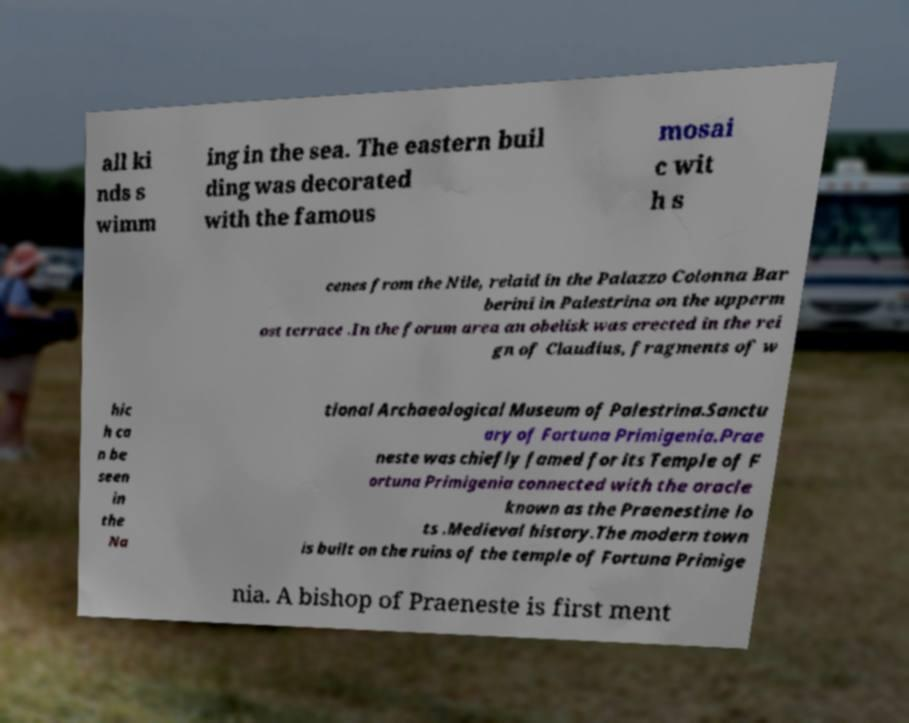Please read and relay the text visible in this image. What does it say? all ki nds s wimm ing in the sea. The eastern buil ding was decorated with the famous mosai c wit h s cenes from the Nile, relaid in the Palazzo Colonna Bar berini in Palestrina on the upperm ost terrace .In the forum area an obelisk was erected in the rei gn of Claudius, fragments of w hic h ca n be seen in the Na tional Archaeological Museum of Palestrina.Sanctu ary of Fortuna Primigenia.Prae neste was chiefly famed for its Temple of F ortuna Primigenia connected with the oracle known as the Praenestine lo ts .Medieval history.The modern town is built on the ruins of the temple of Fortuna Primige nia. A bishop of Praeneste is first ment 